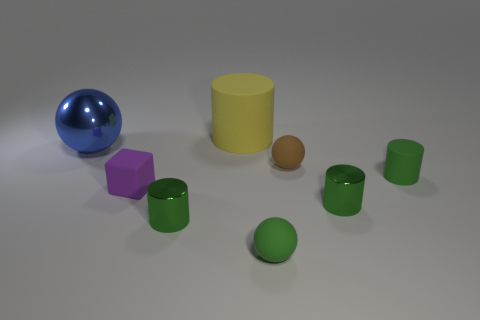Subtract all green cylinders. How many were subtracted if there are1green cylinders left? 2 Subtract all green cubes. How many green cylinders are left? 3 Subtract 1 cylinders. How many cylinders are left? 3 Subtract all large blue metallic spheres. How many spheres are left? 2 Subtract all yellow cylinders. How many cylinders are left? 3 Add 1 purple rubber cubes. How many objects exist? 9 Subtract all blue cylinders. Subtract all purple cubes. How many cylinders are left? 4 Subtract all balls. How many objects are left? 5 Subtract 2 green cylinders. How many objects are left? 6 Subtract all purple cubes. Subtract all small brown matte objects. How many objects are left? 6 